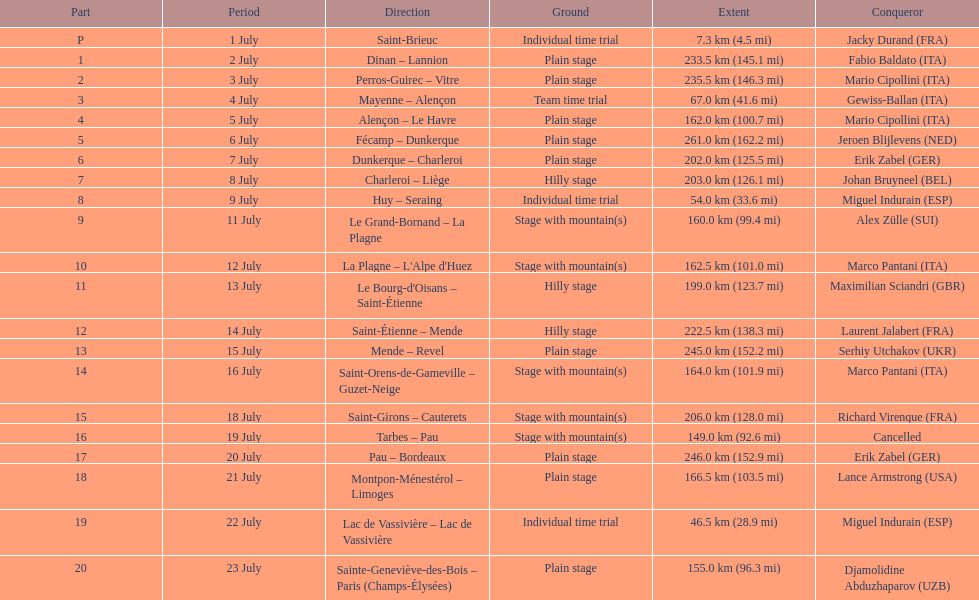What is the length difference between the 20th and 19th stages of the tour de france? 108.5 km. 